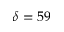<formula> <loc_0><loc_0><loc_500><loc_500>\delta = 5 9</formula> 